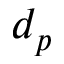<formula> <loc_0><loc_0><loc_500><loc_500>d _ { p }</formula> 